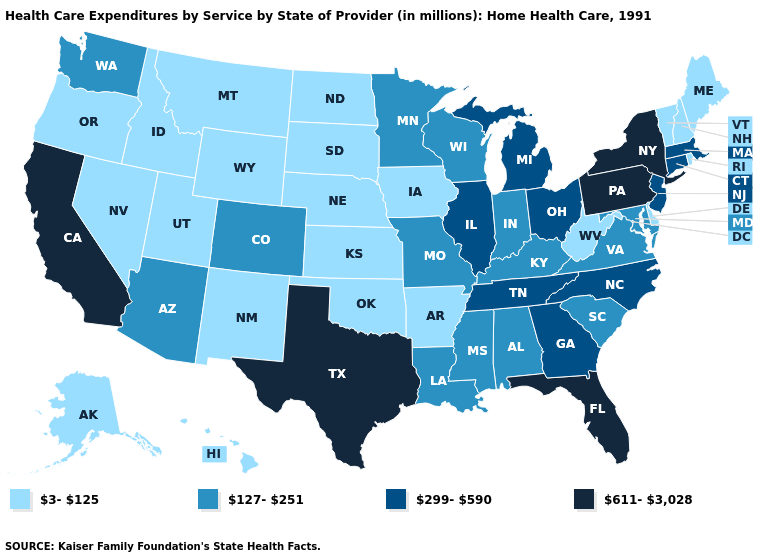Name the states that have a value in the range 3-125?
Short answer required. Alaska, Arkansas, Delaware, Hawaii, Idaho, Iowa, Kansas, Maine, Montana, Nebraska, Nevada, New Hampshire, New Mexico, North Dakota, Oklahoma, Oregon, Rhode Island, South Dakota, Utah, Vermont, West Virginia, Wyoming. Is the legend a continuous bar?
Answer briefly. No. What is the value of Vermont?
Answer briefly. 3-125. Does New Jersey have the lowest value in the Northeast?
Write a very short answer. No. Among the states that border Missouri , which have the lowest value?
Answer briefly. Arkansas, Iowa, Kansas, Nebraska, Oklahoma. What is the value of Georgia?
Write a very short answer. 299-590. Name the states that have a value in the range 3-125?
Keep it brief. Alaska, Arkansas, Delaware, Hawaii, Idaho, Iowa, Kansas, Maine, Montana, Nebraska, Nevada, New Hampshire, New Mexico, North Dakota, Oklahoma, Oregon, Rhode Island, South Dakota, Utah, Vermont, West Virginia, Wyoming. Does Wyoming have the highest value in the USA?
Short answer required. No. Name the states that have a value in the range 127-251?
Concise answer only. Alabama, Arizona, Colorado, Indiana, Kentucky, Louisiana, Maryland, Minnesota, Mississippi, Missouri, South Carolina, Virginia, Washington, Wisconsin. Name the states that have a value in the range 3-125?
Concise answer only. Alaska, Arkansas, Delaware, Hawaii, Idaho, Iowa, Kansas, Maine, Montana, Nebraska, Nevada, New Hampshire, New Mexico, North Dakota, Oklahoma, Oregon, Rhode Island, South Dakota, Utah, Vermont, West Virginia, Wyoming. Name the states that have a value in the range 127-251?
Give a very brief answer. Alabama, Arizona, Colorado, Indiana, Kentucky, Louisiana, Maryland, Minnesota, Mississippi, Missouri, South Carolina, Virginia, Washington, Wisconsin. Name the states that have a value in the range 611-3,028?
Keep it brief. California, Florida, New York, Pennsylvania, Texas. What is the value of South Dakota?
Be succinct. 3-125. Among the states that border Minnesota , which have the lowest value?
Keep it brief. Iowa, North Dakota, South Dakota. Name the states that have a value in the range 611-3,028?
Be succinct. California, Florida, New York, Pennsylvania, Texas. 